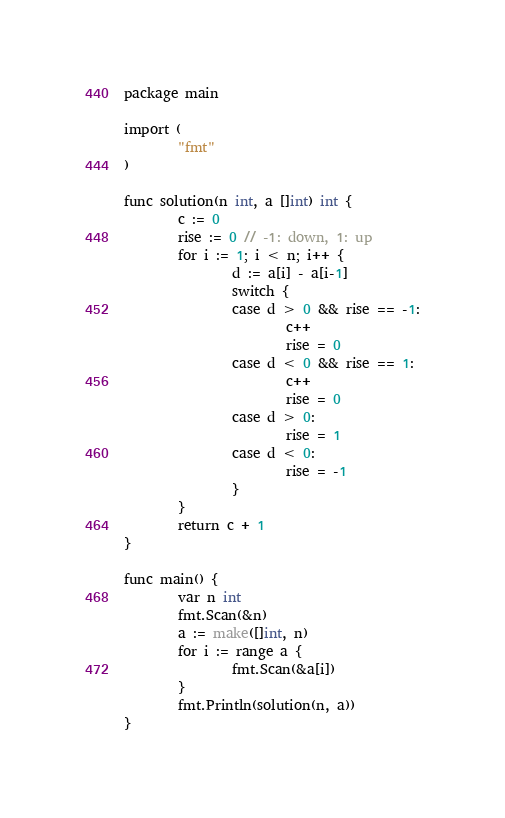Convert code to text. <code><loc_0><loc_0><loc_500><loc_500><_Go_>package main

import (
        "fmt"
)

func solution(n int, a []int) int {
        c := 0
        rise := 0 // -1: down, 1: up
        for i := 1; i < n; i++ {
                d := a[i] - a[i-1]
                switch {
                case d > 0 && rise == -1:
                        c++
                        rise = 0
                case d < 0 && rise == 1:
                        c++
                        rise = 0
                case d > 0:
                        rise = 1
                case d < 0:
                        rise = -1
                }
        }
        return c + 1
}

func main() {
        var n int
        fmt.Scan(&n)
        a := make([]int, n)
        for i := range a {
                fmt.Scan(&a[i])
        }
        fmt.Println(solution(n, a))
}</code> 